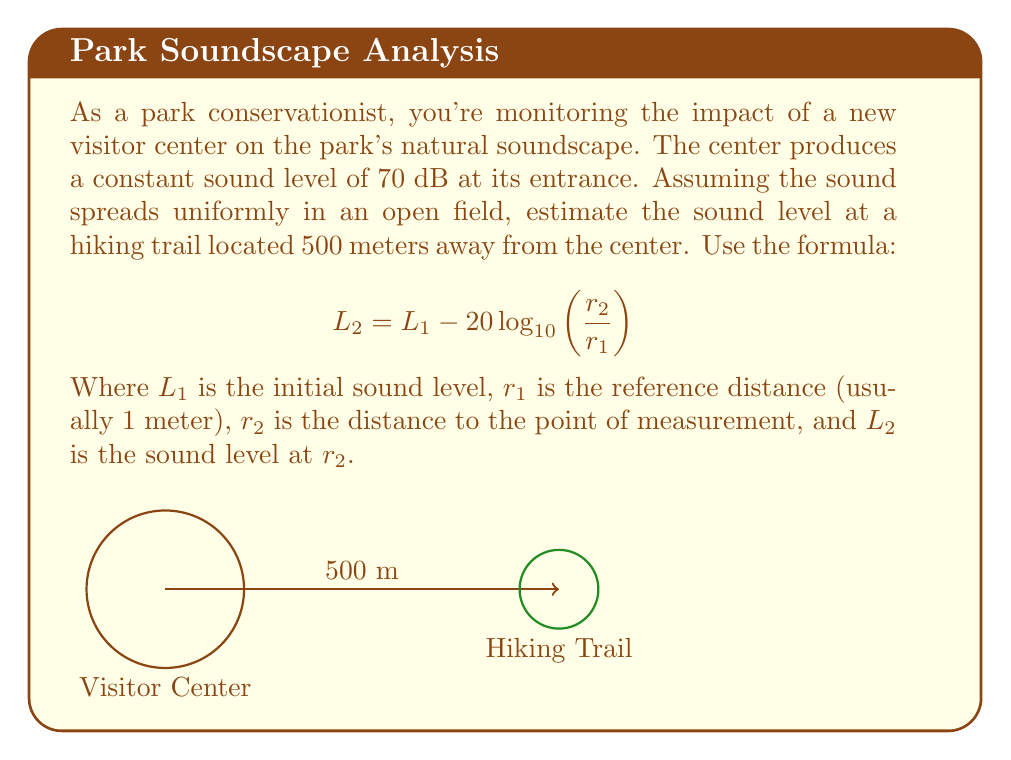Solve this math problem. Let's approach this step-by-step:

1) We are given:
   $L_1 = 70$ dB (initial sound level)
   $r_1 = 1$ meter (reference distance)
   $r_2 = 500$ meters (distance to hiking trail)

2) We'll use the formula:
   $$ L_2 = L_1 - 20 \log_{10}\left(\frac{r_2}{r_1}\right) $$

3) Substituting the values:
   $$ L_2 = 70 - 20 \log_{10}\left(\frac{500}{1}\right) $$

4) Simplify inside the logarithm:
   $$ L_2 = 70 - 20 \log_{10}(500) $$

5) Calculate the logarithm:
   $\log_{10}(500) \approx 2.699$

6) Multiply by 20:
   $20 \times 2.699 = 53.98$

7) Subtract from the initial sound level:
   $$ L_2 = 70 - 53.98 = 16.02 $$

8) Round to the nearest decibel (as sound levels are typically reported):
   $L_2 \approx 16$ dB
Answer: 16 dB 